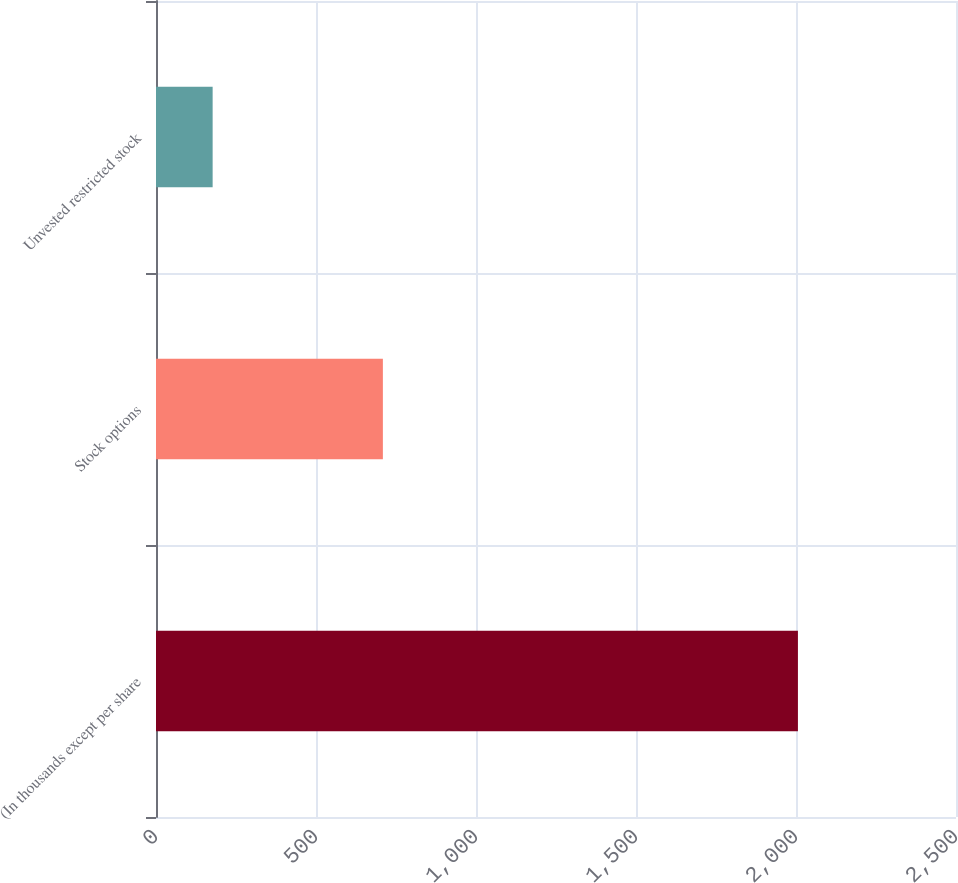<chart> <loc_0><loc_0><loc_500><loc_500><bar_chart><fcel>(In thousands except per share<fcel>Stock options<fcel>Unvested restricted stock<nl><fcel>2006<fcel>709<fcel>177<nl></chart> 